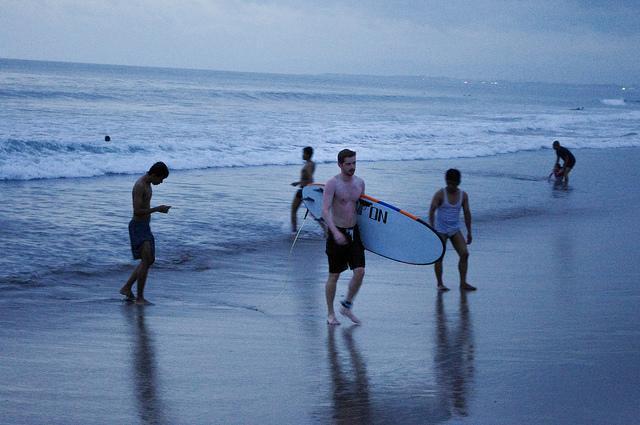How many people are holding a surfboard?
Give a very brief answer. 1. How many people are carrying surfboards?
Give a very brief answer. 1. How many people are visible?
Give a very brief answer. 3. 